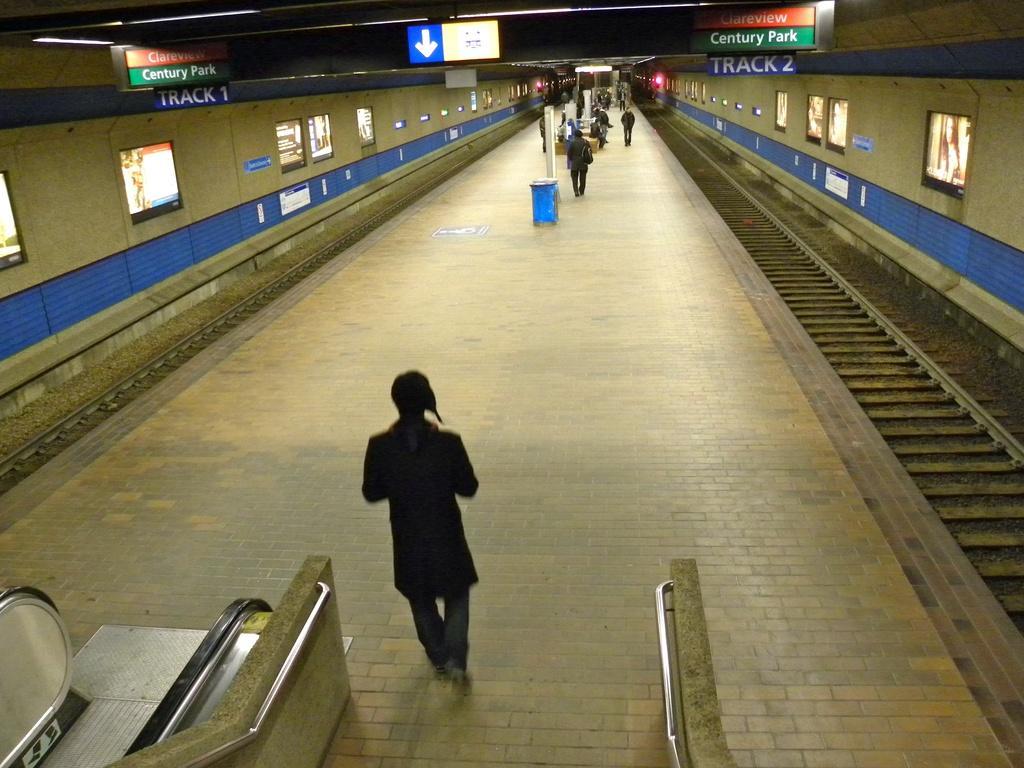Could you give a brief overview of what you see in this image? In the center of the image we can see a platform and there are people. On the left there is an escalator and we can see railings. There are railway tracks. We can see screens and boards. There are lights. 